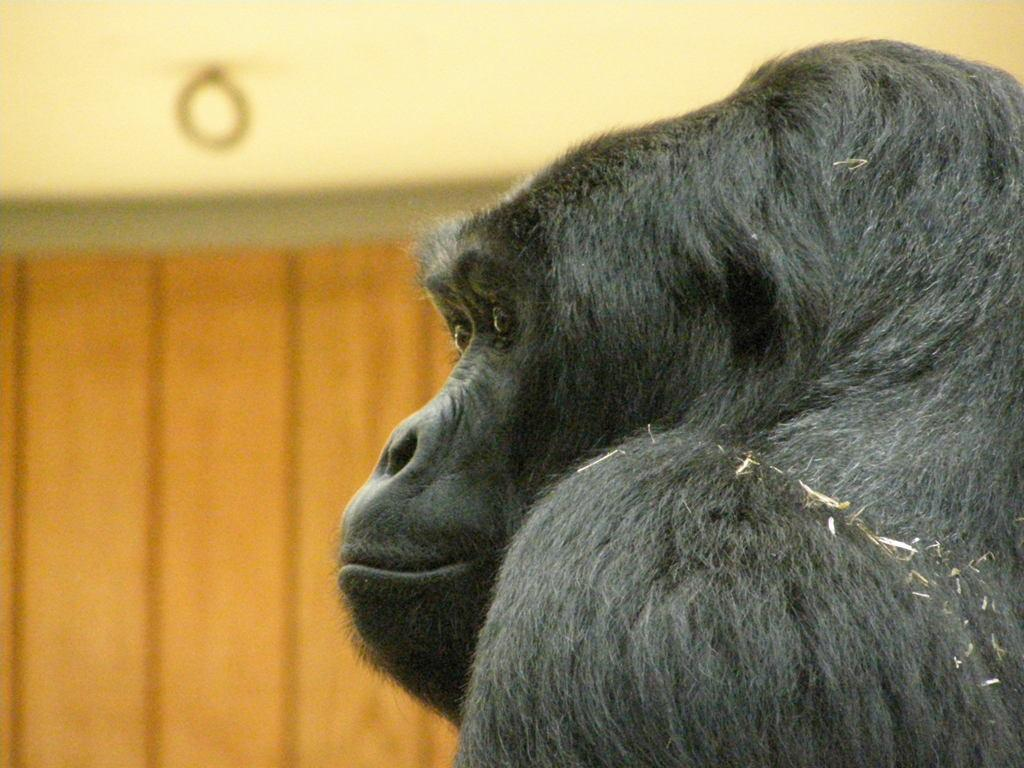What animal is in the center of the image? There is a chimpanzee in the center of the image. What can be seen in the background of the image? There is a wall in the background of the image. How many grapes can be seen in the image? There are no grapes present in the image. 